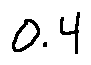<formula> <loc_0><loc_0><loc_500><loc_500>0 . 4</formula> 